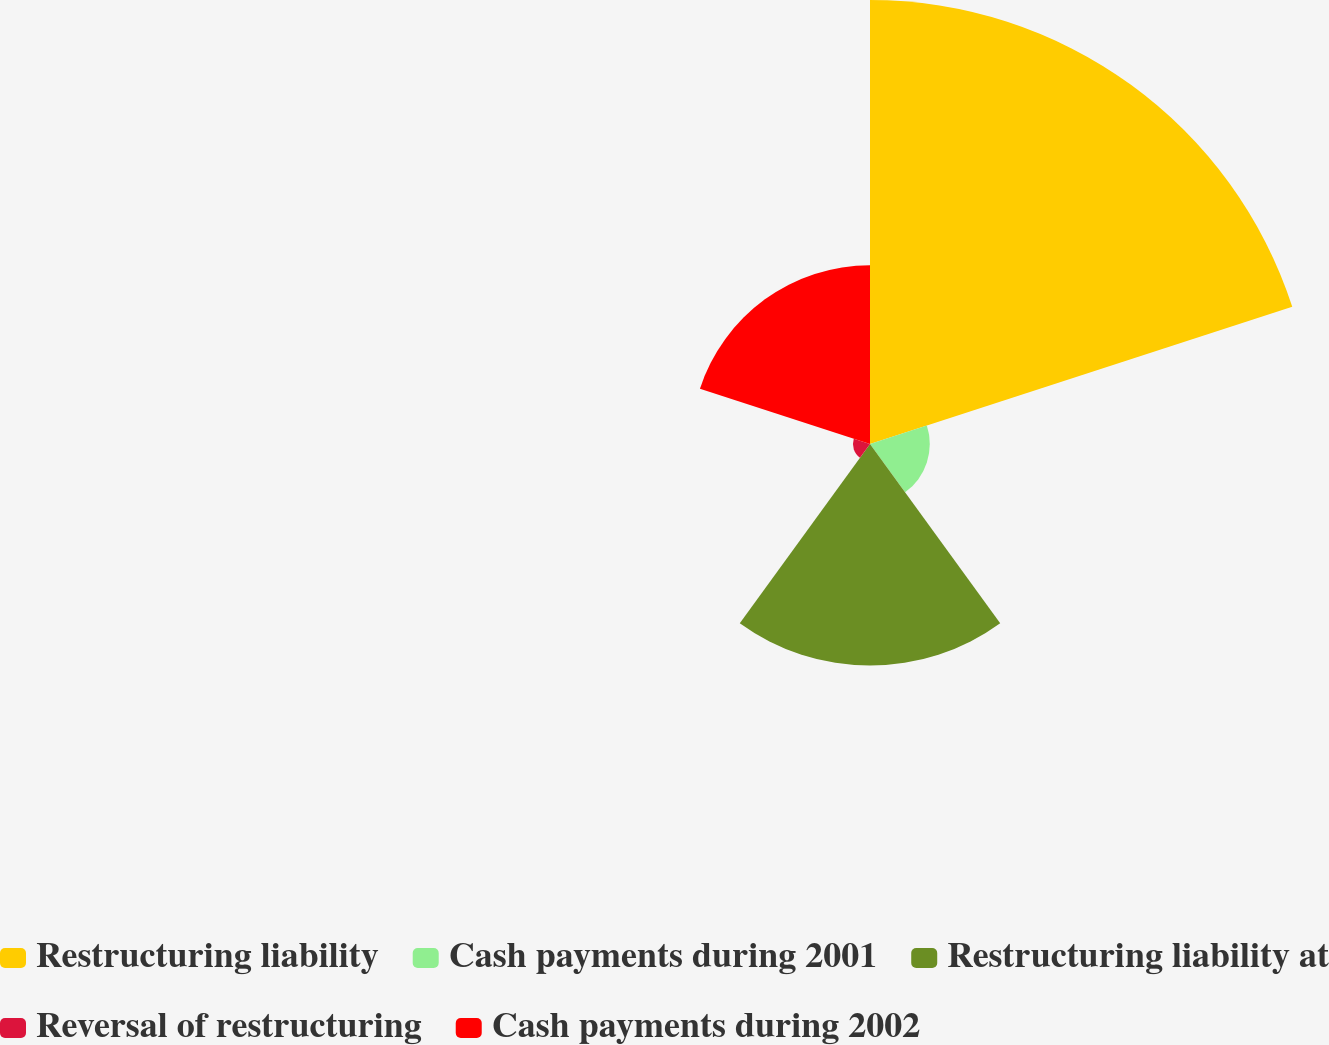<chart> <loc_0><loc_0><loc_500><loc_500><pie_chart><fcel>Restructuring liability<fcel>Cash payments during 2001<fcel>Restructuring liability at<fcel>Reversal of restructuring<fcel>Cash payments during 2002<nl><fcel>48.2%<fcel>6.49%<fcel>24.05%<fcel>1.85%<fcel>19.41%<nl></chart> 